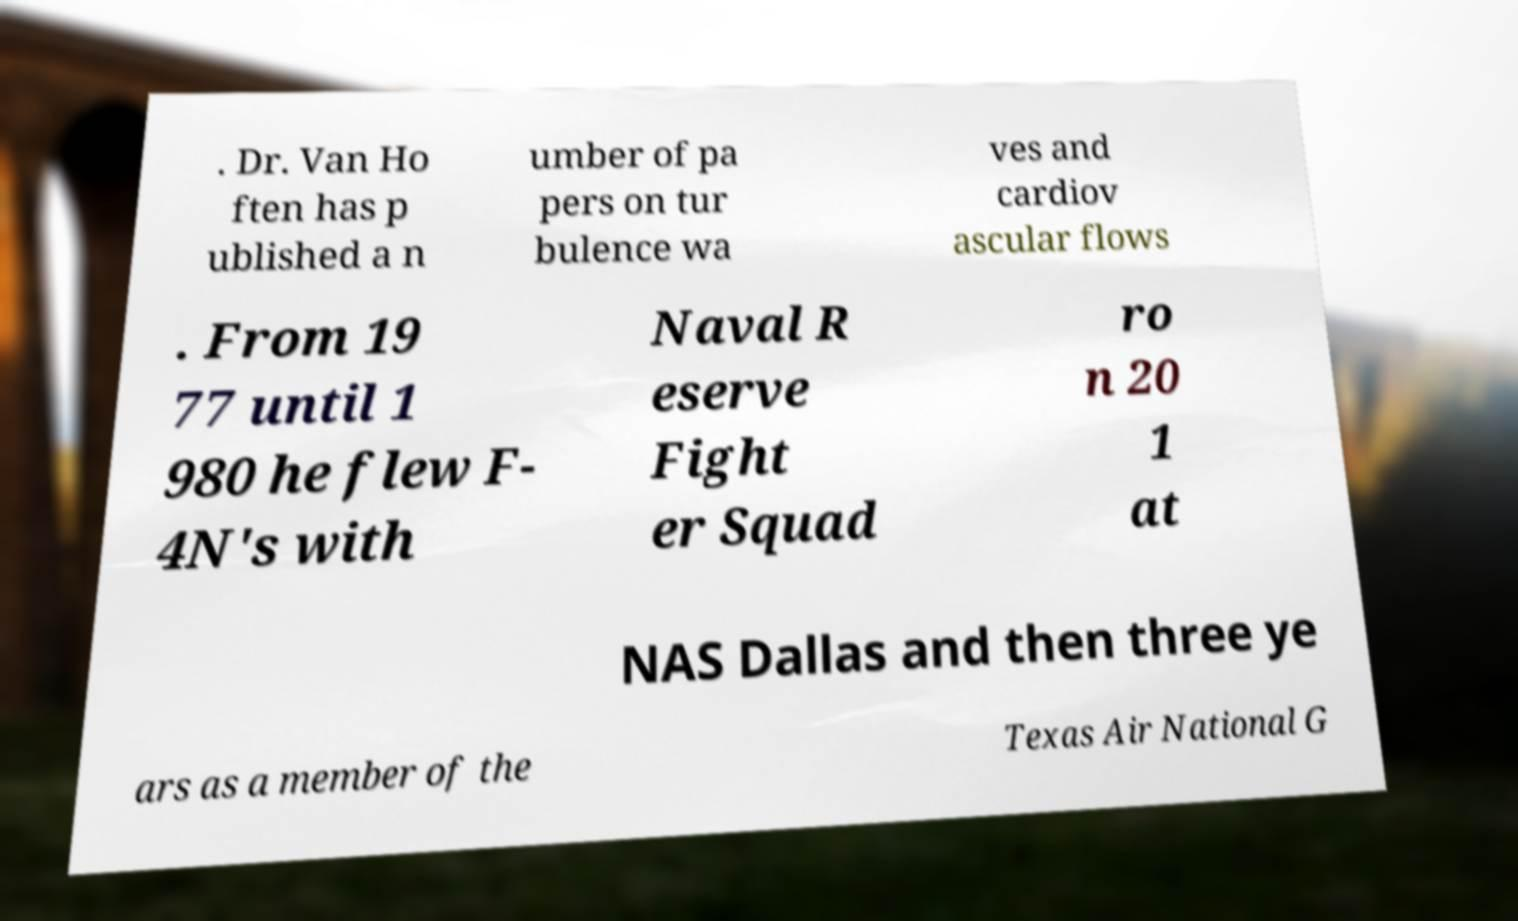Can you accurately transcribe the text from the provided image for me? . Dr. Van Ho ften has p ublished a n umber of pa pers on tur bulence wa ves and cardiov ascular flows . From 19 77 until 1 980 he flew F- 4N's with Naval R eserve Fight er Squad ro n 20 1 at NAS Dallas and then three ye ars as a member of the Texas Air National G 